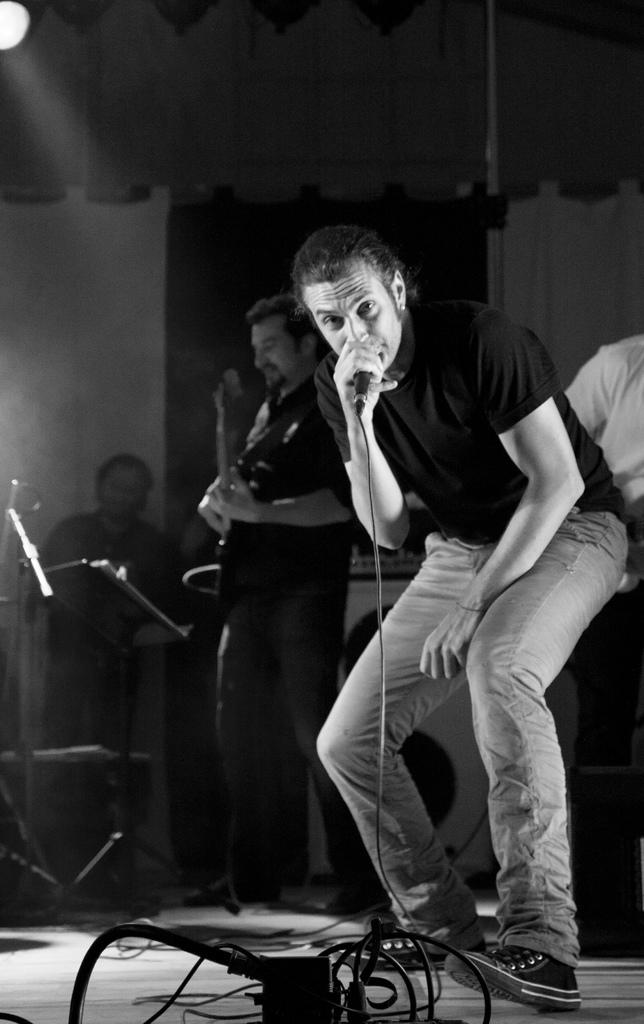What is the man in the image holding in his hand? The man is holding a microphone in his hand. What is the second man in the image holding in his hand? The second man is holding a guitar in his hand. Can you describe the color scheme of the image? The image is in black and white color. How many people are present in the image? There are two people in the image. What type of cherries can be seen in the image? There are no cherries present in the image. What type of business is being conducted in the image? The image does not depict any business activities; it features two men holding a microphone and a guitar. What societal issues are being addressed in the image? The image does not address any societal issues; it is a simple depiction of two men holding musical instruments. 